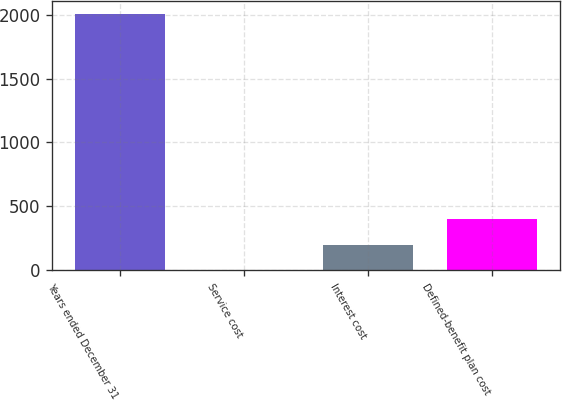Convert chart. <chart><loc_0><loc_0><loc_500><loc_500><bar_chart><fcel>Years ended December 31<fcel>Service cost<fcel>Interest cost<fcel>Defined-benefit plan cost<nl><fcel>2007<fcel>0.2<fcel>200.88<fcel>401.56<nl></chart> 